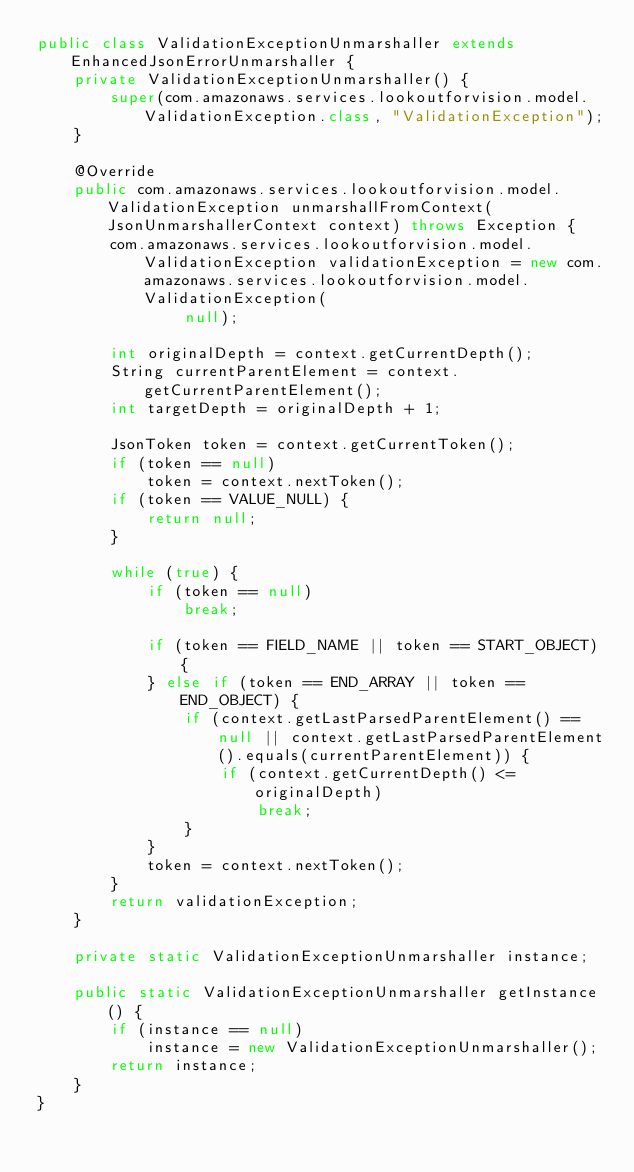<code> <loc_0><loc_0><loc_500><loc_500><_Java_>public class ValidationExceptionUnmarshaller extends EnhancedJsonErrorUnmarshaller {
    private ValidationExceptionUnmarshaller() {
        super(com.amazonaws.services.lookoutforvision.model.ValidationException.class, "ValidationException");
    }

    @Override
    public com.amazonaws.services.lookoutforvision.model.ValidationException unmarshallFromContext(JsonUnmarshallerContext context) throws Exception {
        com.amazonaws.services.lookoutforvision.model.ValidationException validationException = new com.amazonaws.services.lookoutforvision.model.ValidationException(
                null);

        int originalDepth = context.getCurrentDepth();
        String currentParentElement = context.getCurrentParentElement();
        int targetDepth = originalDepth + 1;

        JsonToken token = context.getCurrentToken();
        if (token == null)
            token = context.nextToken();
        if (token == VALUE_NULL) {
            return null;
        }

        while (true) {
            if (token == null)
                break;

            if (token == FIELD_NAME || token == START_OBJECT) {
            } else if (token == END_ARRAY || token == END_OBJECT) {
                if (context.getLastParsedParentElement() == null || context.getLastParsedParentElement().equals(currentParentElement)) {
                    if (context.getCurrentDepth() <= originalDepth)
                        break;
                }
            }
            token = context.nextToken();
        }
        return validationException;
    }

    private static ValidationExceptionUnmarshaller instance;

    public static ValidationExceptionUnmarshaller getInstance() {
        if (instance == null)
            instance = new ValidationExceptionUnmarshaller();
        return instance;
    }
}
</code> 